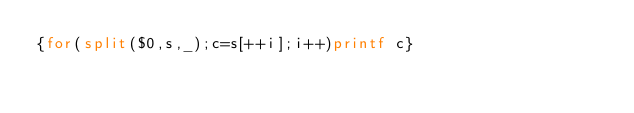Convert code to text. <code><loc_0><loc_0><loc_500><loc_500><_Awk_>{for(split($0,s,_);c=s[++i];i++)printf c}</code> 